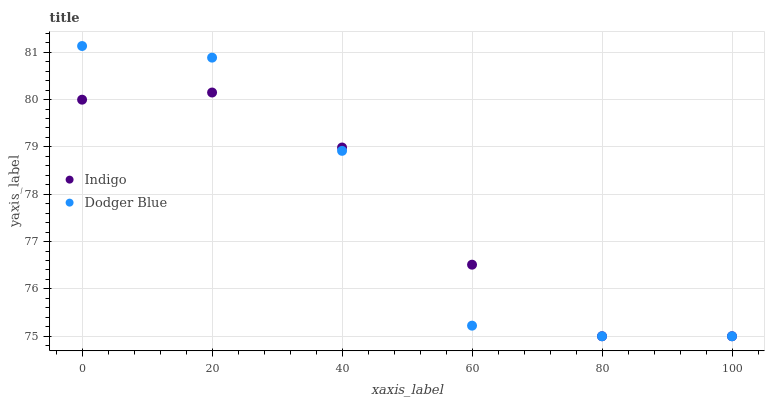Does Dodger Blue have the minimum area under the curve?
Answer yes or no. Yes. Does Indigo have the maximum area under the curve?
Answer yes or no. Yes. Does Indigo have the minimum area under the curve?
Answer yes or no. No. Is Indigo the smoothest?
Answer yes or no. Yes. Is Dodger Blue the roughest?
Answer yes or no. Yes. Is Indigo the roughest?
Answer yes or no. No. Does Dodger Blue have the lowest value?
Answer yes or no. Yes. Does Dodger Blue have the highest value?
Answer yes or no. Yes. Does Indigo have the highest value?
Answer yes or no. No. Does Dodger Blue intersect Indigo?
Answer yes or no. Yes. Is Dodger Blue less than Indigo?
Answer yes or no. No. Is Dodger Blue greater than Indigo?
Answer yes or no. No. 